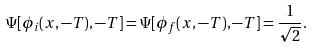<formula> <loc_0><loc_0><loc_500><loc_500>\Psi [ \phi _ { i } ( x , - T ) , - T ] = \Psi [ \phi _ { f } ( x , - T ) , - T ] = \frac { 1 } { \sqrt { 2 } } .</formula> 